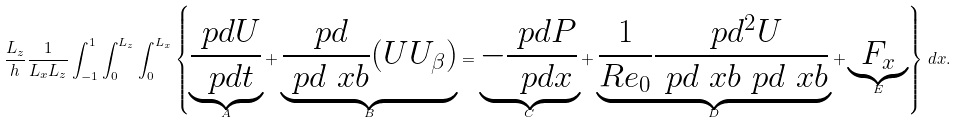Convert formula to latex. <formula><loc_0><loc_0><loc_500><loc_500>\frac { L _ { z } } { h } \frac { 1 } { L _ { x } L _ { z } } \int ^ { 1 } _ { - 1 } \int _ { 0 } ^ { L _ { z } } \int _ { 0 } ^ { L _ { x } } \left \{ \underbrace { \frac { \ p d U } { \ p d t } } _ { A } + \underbrace { \frac { \ p d } { \ p d \ x b } ( U U _ { \beta } ) } _ { B } = \underbrace { - \frac { \ p d P } { \ p d x } } _ { C } + \underbrace { \frac { 1 } { R e _ { 0 } } \frac { \ p d ^ { 2 } U } { \ p d \ x b \ p d \ x b } } _ { D } + \underbrace { F _ { x } } _ { E } \right \} \, d { x } .</formula> 